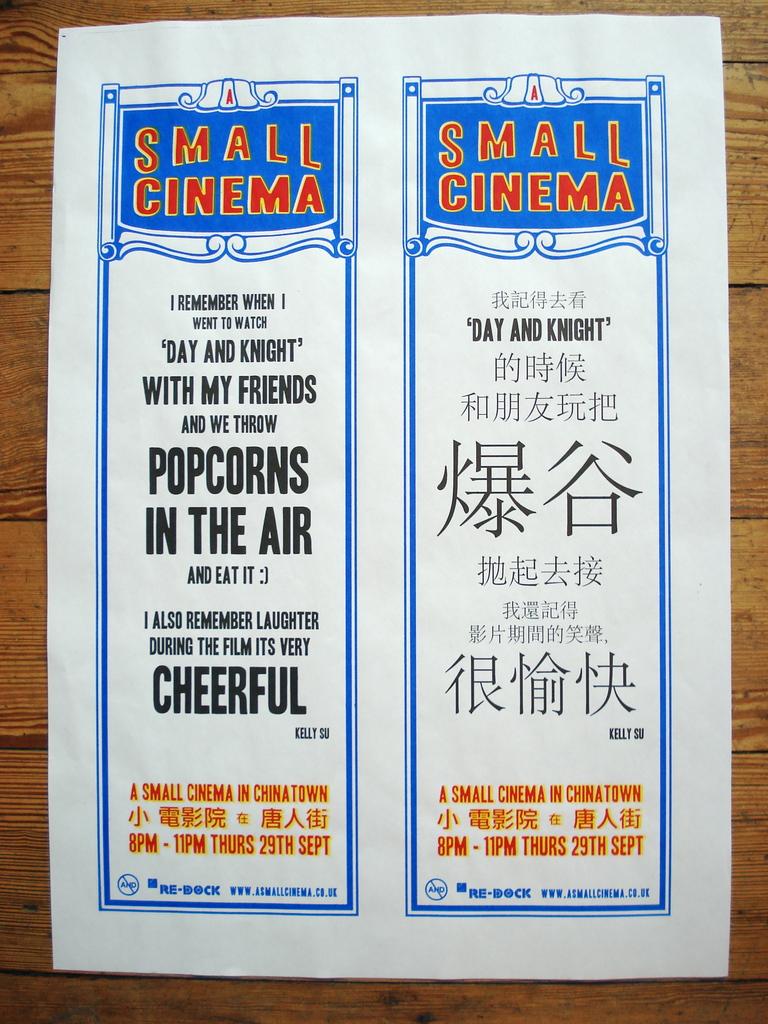What size of cinema?
Your answer should be compact. Small. What did they do with the popcorn?
Keep it short and to the point. Threw in the air. 